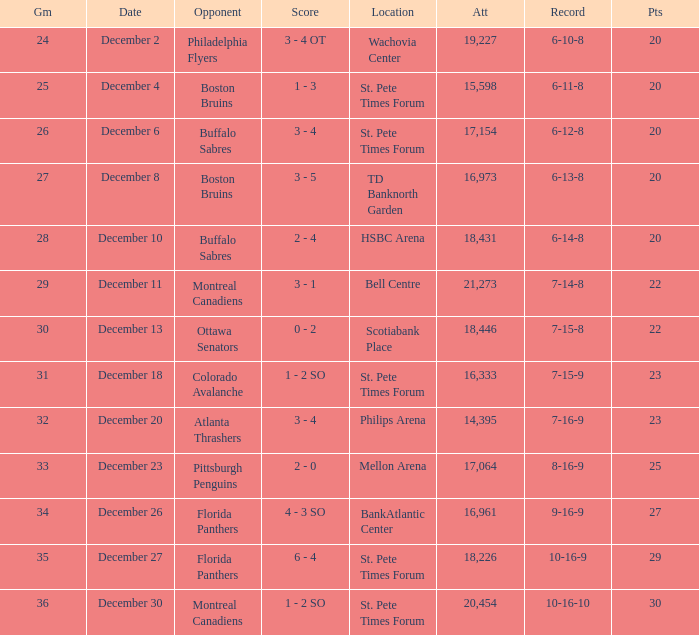What is the location of the game with a 6-11-8 record? St. Pete Times Forum. 